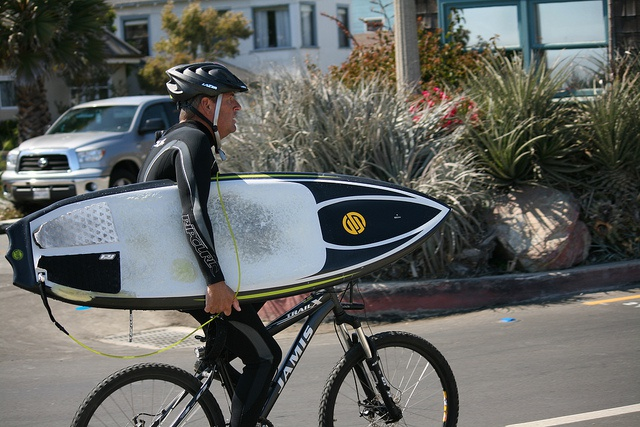Describe the objects in this image and their specific colors. I can see surfboard in black, darkgray, and gray tones, bicycle in black, darkgray, and gray tones, people in black, gray, darkgray, and brown tones, and truck in black, gray, lightgray, and darkgray tones in this image. 